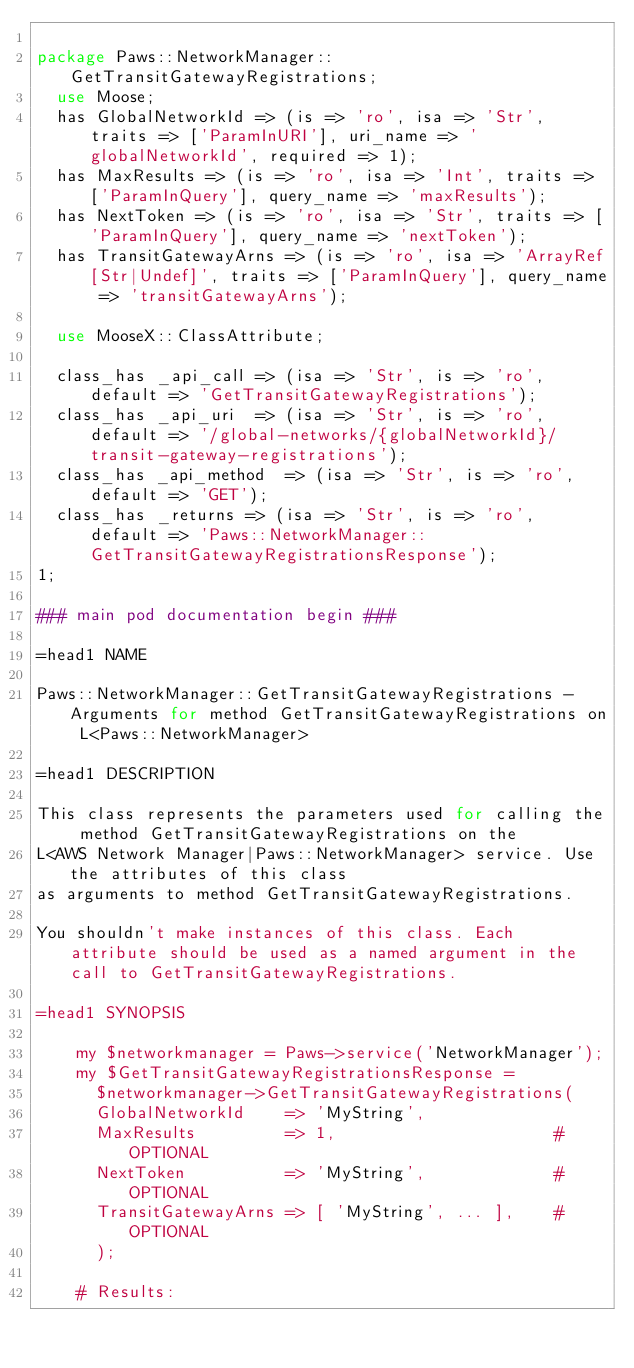<code> <loc_0><loc_0><loc_500><loc_500><_Perl_>
package Paws::NetworkManager::GetTransitGatewayRegistrations;
  use Moose;
  has GlobalNetworkId => (is => 'ro', isa => 'Str', traits => ['ParamInURI'], uri_name => 'globalNetworkId', required => 1);
  has MaxResults => (is => 'ro', isa => 'Int', traits => ['ParamInQuery'], query_name => 'maxResults');
  has NextToken => (is => 'ro', isa => 'Str', traits => ['ParamInQuery'], query_name => 'nextToken');
  has TransitGatewayArns => (is => 'ro', isa => 'ArrayRef[Str|Undef]', traits => ['ParamInQuery'], query_name => 'transitGatewayArns');

  use MooseX::ClassAttribute;

  class_has _api_call => (isa => 'Str', is => 'ro', default => 'GetTransitGatewayRegistrations');
  class_has _api_uri  => (isa => 'Str', is => 'ro', default => '/global-networks/{globalNetworkId}/transit-gateway-registrations');
  class_has _api_method  => (isa => 'Str', is => 'ro', default => 'GET');
  class_has _returns => (isa => 'Str', is => 'ro', default => 'Paws::NetworkManager::GetTransitGatewayRegistrationsResponse');
1;

### main pod documentation begin ###

=head1 NAME

Paws::NetworkManager::GetTransitGatewayRegistrations - Arguments for method GetTransitGatewayRegistrations on L<Paws::NetworkManager>

=head1 DESCRIPTION

This class represents the parameters used for calling the method GetTransitGatewayRegistrations on the
L<AWS Network Manager|Paws::NetworkManager> service. Use the attributes of this class
as arguments to method GetTransitGatewayRegistrations.

You shouldn't make instances of this class. Each attribute should be used as a named argument in the call to GetTransitGatewayRegistrations.

=head1 SYNOPSIS

    my $networkmanager = Paws->service('NetworkManager');
    my $GetTransitGatewayRegistrationsResponse =
      $networkmanager->GetTransitGatewayRegistrations(
      GlobalNetworkId    => 'MyString',
      MaxResults         => 1,                      # OPTIONAL
      NextToken          => 'MyString',             # OPTIONAL
      TransitGatewayArns => [ 'MyString', ... ],    # OPTIONAL
      );

    # Results:</code> 